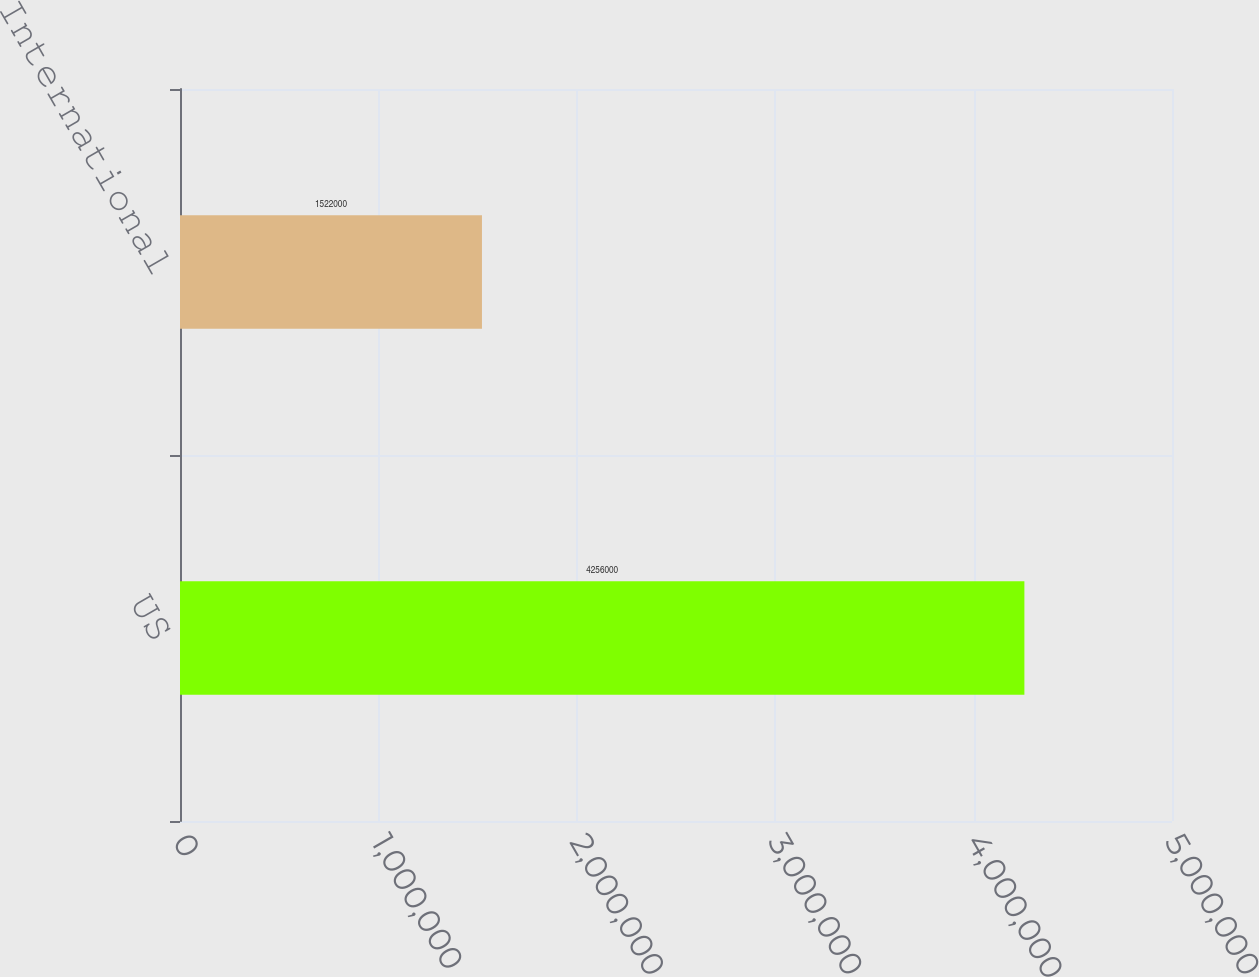Convert chart. <chart><loc_0><loc_0><loc_500><loc_500><bar_chart><fcel>US<fcel>International<nl><fcel>4.256e+06<fcel>1.522e+06<nl></chart> 